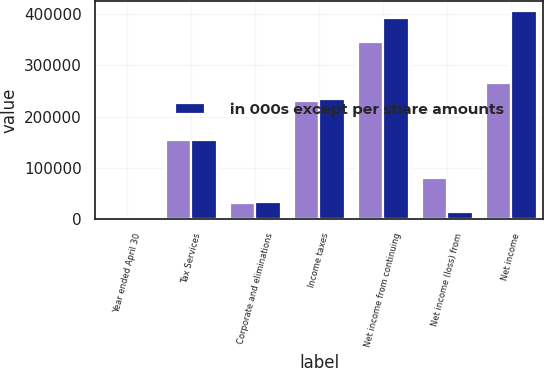Convert chart. <chart><loc_0><loc_0><loc_500><loc_500><stacked_bar_chart><ecel><fcel>Year ended April 30<fcel>Tax Services<fcel>Corporate and eliminations<fcel>Income taxes<fcel>Net income from continuing<fcel>Net income (loss) from<fcel>Net income<nl><fcel>nan<fcel>2012<fcel>155069<fcel>31393<fcel>230102<fcel>345968<fcel>80036<fcel>265932<nl><fcel>in 000s except per share amounts<fcel>2011<fcel>155069<fcel>32619<fcel>235156<fcel>392547<fcel>13563<fcel>406110<nl></chart> 